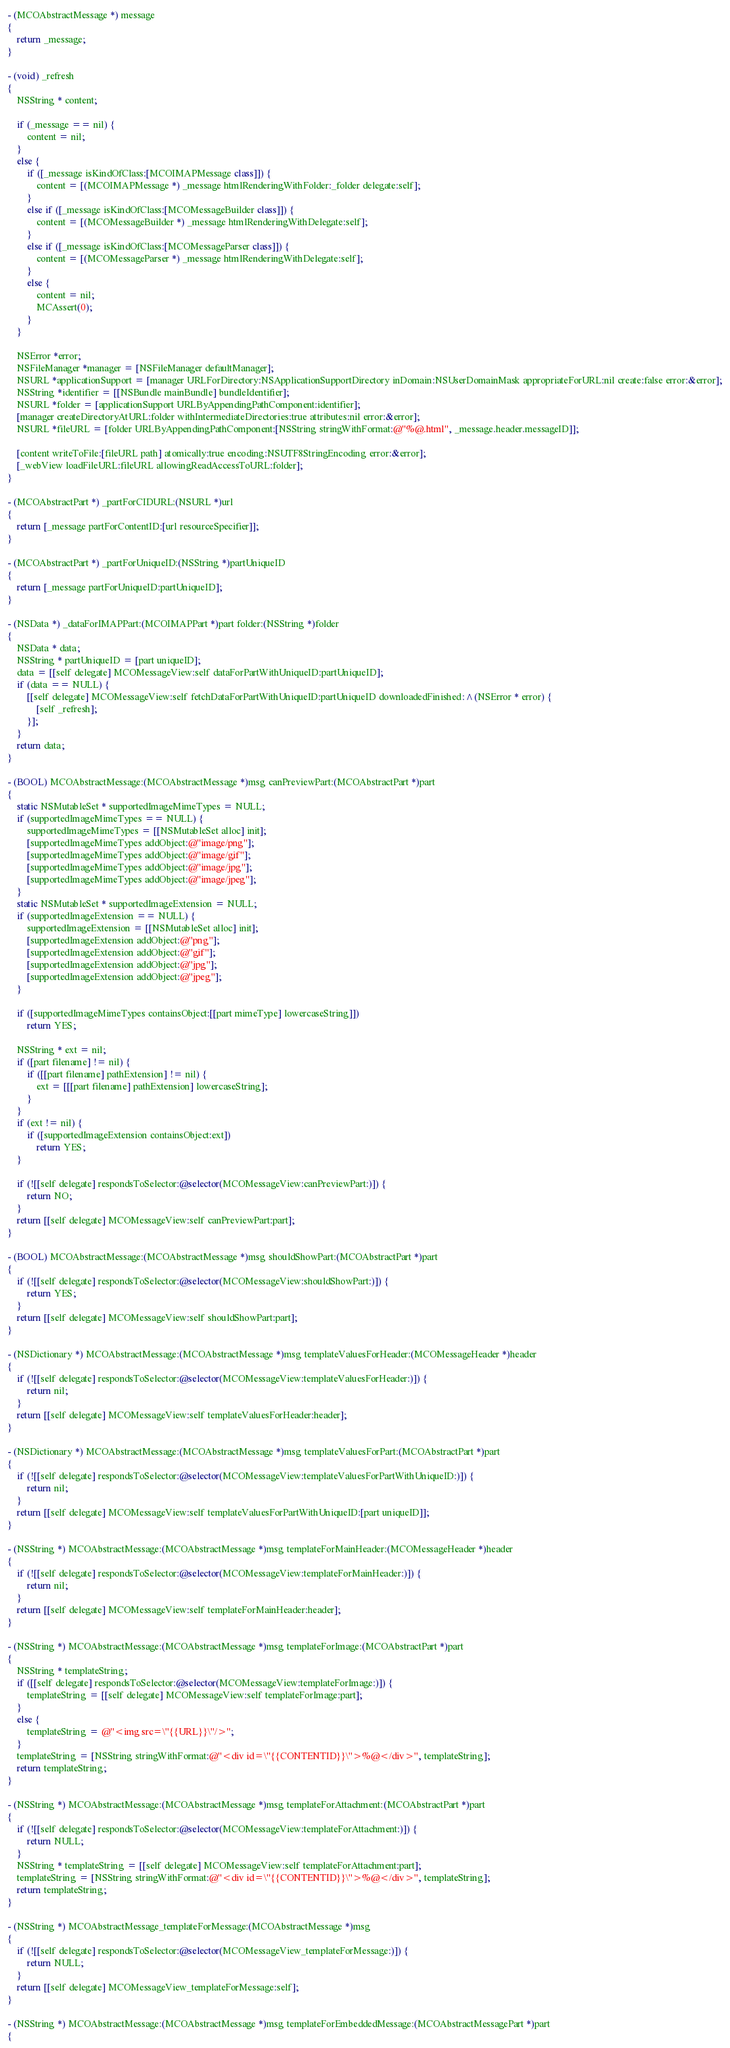<code> <loc_0><loc_0><loc_500><loc_500><_ObjectiveC_>- (MCOAbstractMessage *) message
{
    return _message;
}

- (void) _refresh
{
    NSString * content;
    
    if (_message == nil) {
        content = nil;
    }
    else {
        if ([_message isKindOfClass:[MCOIMAPMessage class]]) {
            content = [(MCOIMAPMessage *) _message htmlRenderingWithFolder:_folder delegate:self];
        }
        else if ([_message isKindOfClass:[MCOMessageBuilder class]]) {
            content = [(MCOMessageBuilder *) _message htmlRenderingWithDelegate:self];
        }
        else if ([_message isKindOfClass:[MCOMessageParser class]]) {
            content = [(MCOMessageParser *) _message htmlRenderingWithDelegate:self];
        }
        else {
            content = nil;
            MCAssert(0);
        }
    }

    NSError *error;
    NSFileManager *manager = [NSFileManager defaultManager];
    NSURL *applicationSupport = [manager URLForDirectory:NSApplicationSupportDirectory inDomain:NSUserDomainMask appropriateForURL:nil create:false error:&error];
    NSString *identifier = [[NSBundle mainBundle] bundleIdentifier];
    NSURL *folder = [applicationSupport URLByAppendingPathComponent:identifier];
    [manager createDirectoryAtURL:folder withIntermediateDirectories:true attributes:nil error:&error];
    NSURL *fileURL = [folder URLByAppendingPathComponent:[NSString stringWithFormat:@"%@.html", _message.header.messageID]];

    [content writeToFile:[fileURL path] atomically:true encoding:NSUTF8StringEncoding error:&error];
    [_webView loadFileURL:fileURL allowingReadAccessToURL:folder];
}

- (MCOAbstractPart *) _partForCIDURL:(NSURL *)url
{
    return [_message partForContentID:[url resourceSpecifier]];
}

- (MCOAbstractPart *) _partForUniqueID:(NSString *)partUniqueID
{
    return [_message partForUniqueID:partUniqueID];
}

- (NSData *) _dataForIMAPPart:(MCOIMAPPart *)part folder:(NSString *)folder
{
    NSData * data;
    NSString * partUniqueID = [part uniqueID];
    data = [[self delegate] MCOMessageView:self dataForPartWithUniqueID:partUniqueID];
    if (data == NULL) {
        [[self delegate] MCOMessageView:self fetchDataForPartWithUniqueID:partUniqueID downloadedFinished:^(NSError * error) {
            [self _refresh];
        }];
    }
    return data;
}

- (BOOL) MCOAbstractMessage:(MCOAbstractMessage *)msg canPreviewPart:(MCOAbstractPart *)part
{
    static NSMutableSet * supportedImageMimeTypes = NULL;
    if (supportedImageMimeTypes == NULL) {
        supportedImageMimeTypes = [[NSMutableSet alloc] init];
        [supportedImageMimeTypes addObject:@"image/png"];
        [supportedImageMimeTypes addObject:@"image/gif"];
        [supportedImageMimeTypes addObject:@"image/jpg"];
        [supportedImageMimeTypes addObject:@"image/jpeg"];
    }
    static NSMutableSet * supportedImageExtension = NULL;
    if (supportedImageExtension == NULL) {
        supportedImageExtension = [[NSMutableSet alloc] init];
        [supportedImageExtension addObject:@"png"];
        [supportedImageExtension addObject:@"gif"];
        [supportedImageExtension addObject:@"jpg"];
        [supportedImageExtension addObject:@"jpeg"];
    }
    
    if ([supportedImageMimeTypes containsObject:[[part mimeType] lowercaseString]])
        return YES;
    
    NSString * ext = nil;
    if ([part filename] != nil) {
        if ([[part filename] pathExtension] != nil) {
            ext = [[[part filename] pathExtension] lowercaseString];
        }
    }
    if (ext != nil) {
        if ([supportedImageExtension containsObject:ext])
            return YES;
    }
    
    if (![[self delegate] respondsToSelector:@selector(MCOMessageView:canPreviewPart:)]) {
        return NO;
    }
    return [[self delegate] MCOMessageView:self canPreviewPart:part];
}

- (BOOL) MCOAbstractMessage:(MCOAbstractMessage *)msg shouldShowPart:(MCOAbstractPart *)part
{
    if (![[self delegate] respondsToSelector:@selector(MCOMessageView:shouldShowPart:)]) {
        return YES;
    }
    return [[self delegate] MCOMessageView:self shouldShowPart:part];
}

- (NSDictionary *) MCOAbstractMessage:(MCOAbstractMessage *)msg templateValuesForHeader:(MCOMessageHeader *)header
{
    if (![[self delegate] respondsToSelector:@selector(MCOMessageView:templateValuesForHeader:)]) {
        return nil;
    }
    return [[self delegate] MCOMessageView:self templateValuesForHeader:header];
}

- (NSDictionary *) MCOAbstractMessage:(MCOAbstractMessage *)msg templateValuesForPart:(MCOAbstractPart *)part
{
    if (![[self delegate] respondsToSelector:@selector(MCOMessageView:templateValuesForPartWithUniqueID:)]) {
        return nil;
    }
    return [[self delegate] MCOMessageView:self templateValuesForPartWithUniqueID:[part uniqueID]];
}

- (NSString *) MCOAbstractMessage:(MCOAbstractMessage *)msg templateForMainHeader:(MCOMessageHeader *)header
{
    if (![[self delegate] respondsToSelector:@selector(MCOMessageView:templateForMainHeader:)]) {
        return nil;
    }
    return [[self delegate] MCOMessageView:self templateForMainHeader:header];
}

- (NSString *) MCOAbstractMessage:(MCOAbstractMessage *)msg templateForImage:(MCOAbstractPart *)part
{
    NSString * templateString;
    if ([[self delegate] respondsToSelector:@selector(MCOMessageView:templateForImage:)]) {
        templateString = [[self delegate] MCOMessageView:self templateForImage:part];
    }
    else {
        templateString = @"<img src=\"{{URL}}\"/>";
    }
    templateString = [NSString stringWithFormat:@"<div id=\"{{CONTENTID}}\">%@</div>", templateString];
    return templateString;
}

- (NSString *) MCOAbstractMessage:(MCOAbstractMessage *)msg templateForAttachment:(MCOAbstractPart *)part
{
    if (![[self delegate] respondsToSelector:@selector(MCOMessageView:templateForAttachment:)]) {
        return NULL;
    }
    NSString * templateString = [[self delegate] MCOMessageView:self templateForAttachment:part];
    templateString = [NSString stringWithFormat:@"<div id=\"{{CONTENTID}}\">%@</div>", templateString];
    return templateString;
}

- (NSString *) MCOAbstractMessage_templateForMessage:(MCOAbstractMessage *)msg
{
    if (![[self delegate] respondsToSelector:@selector(MCOMessageView_templateForMessage:)]) {
        return NULL;
    }
    return [[self delegate] MCOMessageView_templateForMessage:self];
}

- (NSString *) MCOAbstractMessage:(MCOAbstractMessage *)msg templateForEmbeddedMessage:(MCOAbstractMessagePart *)part
{</code> 